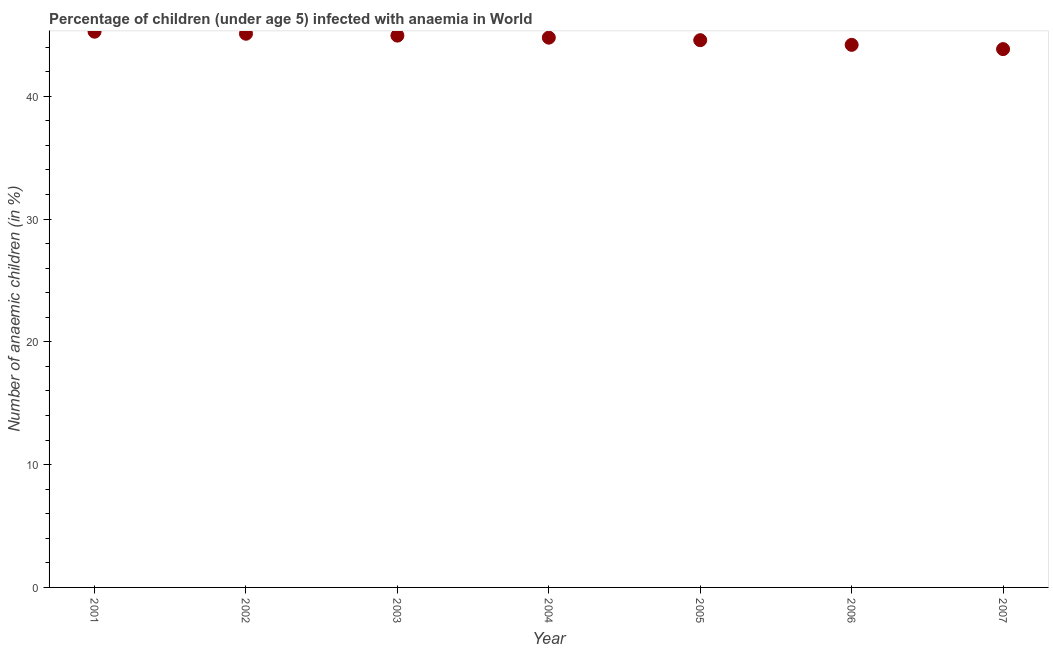What is the number of anaemic children in 2006?
Provide a succinct answer. 44.19. Across all years, what is the maximum number of anaemic children?
Your answer should be very brief. 45.26. Across all years, what is the minimum number of anaemic children?
Your answer should be very brief. 43.84. What is the sum of the number of anaemic children?
Your answer should be compact. 312.66. What is the difference between the number of anaemic children in 2001 and 2007?
Provide a short and direct response. 1.42. What is the average number of anaemic children per year?
Your answer should be very brief. 44.67. What is the median number of anaemic children?
Offer a very short reply. 44.77. In how many years, is the number of anaemic children greater than 14 %?
Give a very brief answer. 7. What is the ratio of the number of anaemic children in 2002 to that in 2007?
Keep it short and to the point. 1.03. Is the difference between the number of anaemic children in 2001 and 2004 greater than the difference between any two years?
Your answer should be very brief. No. What is the difference between the highest and the second highest number of anaemic children?
Make the answer very short. 0.17. What is the difference between the highest and the lowest number of anaemic children?
Ensure brevity in your answer.  1.42. Does the number of anaemic children monotonically increase over the years?
Offer a very short reply. No. What is the difference between two consecutive major ticks on the Y-axis?
Ensure brevity in your answer.  10. What is the title of the graph?
Offer a terse response. Percentage of children (under age 5) infected with anaemia in World. What is the label or title of the X-axis?
Offer a very short reply. Year. What is the label or title of the Y-axis?
Your response must be concise. Number of anaemic children (in %). What is the Number of anaemic children (in %) in 2001?
Your answer should be compact. 45.26. What is the Number of anaemic children (in %) in 2002?
Offer a very short reply. 45.09. What is the Number of anaemic children (in %) in 2003?
Offer a terse response. 44.94. What is the Number of anaemic children (in %) in 2004?
Offer a very short reply. 44.77. What is the Number of anaemic children (in %) in 2005?
Your answer should be very brief. 44.57. What is the Number of anaemic children (in %) in 2006?
Provide a succinct answer. 44.19. What is the Number of anaemic children (in %) in 2007?
Your answer should be compact. 43.84. What is the difference between the Number of anaemic children (in %) in 2001 and 2002?
Give a very brief answer. 0.17. What is the difference between the Number of anaemic children (in %) in 2001 and 2003?
Keep it short and to the point. 0.32. What is the difference between the Number of anaemic children (in %) in 2001 and 2004?
Keep it short and to the point. 0.48. What is the difference between the Number of anaemic children (in %) in 2001 and 2005?
Offer a terse response. 0.69. What is the difference between the Number of anaemic children (in %) in 2001 and 2006?
Keep it short and to the point. 1.07. What is the difference between the Number of anaemic children (in %) in 2001 and 2007?
Ensure brevity in your answer.  1.42. What is the difference between the Number of anaemic children (in %) in 2002 and 2003?
Your answer should be compact. 0.15. What is the difference between the Number of anaemic children (in %) in 2002 and 2004?
Make the answer very short. 0.32. What is the difference between the Number of anaemic children (in %) in 2002 and 2005?
Your answer should be compact. 0.53. What is the difference between the Number of anaemic children (in %) in 2002 and 2006?
Keep it short and to the point. 0.9. What is the difference between the Number of anaemic children (in %) in 2002 and 2007?
Offer a very short reply. 1.25. What is the difference between the Number of anaemic children (in %) in 2003 and 2004?
Give a very brief answer. 0.17. What is the difference between the Number of anaemic children (in %) in 2003 and 2005?
Offer a terse response. 0.37. What is the difference between the Number of anaemic children (in %) in 2003 and 2006?
Provide a short and direct response. 0.75. What is the difference between the Number of anaemic children (in %) in 2003 and 2007?
Your answer should be compact. 1.1. What is the difference between the Number of anaemic children (in %) in 2004 and 2005?
Give a very brief answer. 0.21. What is the difference between the Number of anaemic children (in %) in 2004 and 2006?
Your answer should be compact. 0.59. What is the difference between the Number of anaemic children (in %) in 2004 and 2007?
Offer a very short reply. 0.93. What is the difference between the Number of anaemic children (in %) in 2005 and 2006?
Provide a short and direct response. 0.38. What is the difference between the Number of anaemic children (in %) in 2005 and 2007?
Ensure brevity in your answer.  0.73. What is the difference between the Number of anaemic children (in %) in 2006 and 2007?
Offer a terse response. 0.35. What is the ratio of the Number of anaemic children (in %) in 2001 to that in 2003?
Offer a terse response. 1.01. What is the ratio of the Number of anaemic children (in %) in 2001 to that in 2006?
Ensure brevity in your answer.  1.02. What is the ratio of the Number of anaemic children (in %) in 2001 to that in 2007?
Make the answer very short. 1.03. What is the ratio of the Number of anaemic children (in %) in 2002 to that in 2003?
Offer a terse response. 1. What is the ratio of the Number of anaemic children (in %) in 2002 to that in 2004?
Offer a very short reply. 1.01. What is the ratio of the Number of anaemic children (in %) in 2002 to that in 2005?
Provide a short and direct response. 1.01. What is the ratio of the Number of anaemic children (in %) in 2002 to that in 2007?
Provide a short and direct response. 1.03. What is the ratio of the Number of anaemic children (in %) in 2003 to that in 2005?
Provide a succinct answer. 1.01. What is the ratio of the Number of anaemic children (in %) in 2003 to that in 2006?
Your response must be concise. 1.02. What is the ratio of the Number of anaemic children (in %) in 2004 to that in 2005?
Keep it short and to the point. 1. What is the ratio of the Number of anaemic children (in %) in 2004 to that in 2006?
Your response must be concise. 1.01. What is the ratio of the Number of anaemic children (in %) in 2004 to that in 2007?
Keep it short and to the point. 1.02. What is the ratio of the Number of anaemic children (in %) in 2005 to that in 2006?
Offer a very short reply. 1.01. What is the ratio of the Number of anaemic children (in %) in 2005 to that in 2007?
Offer a terse response. 1.02. 